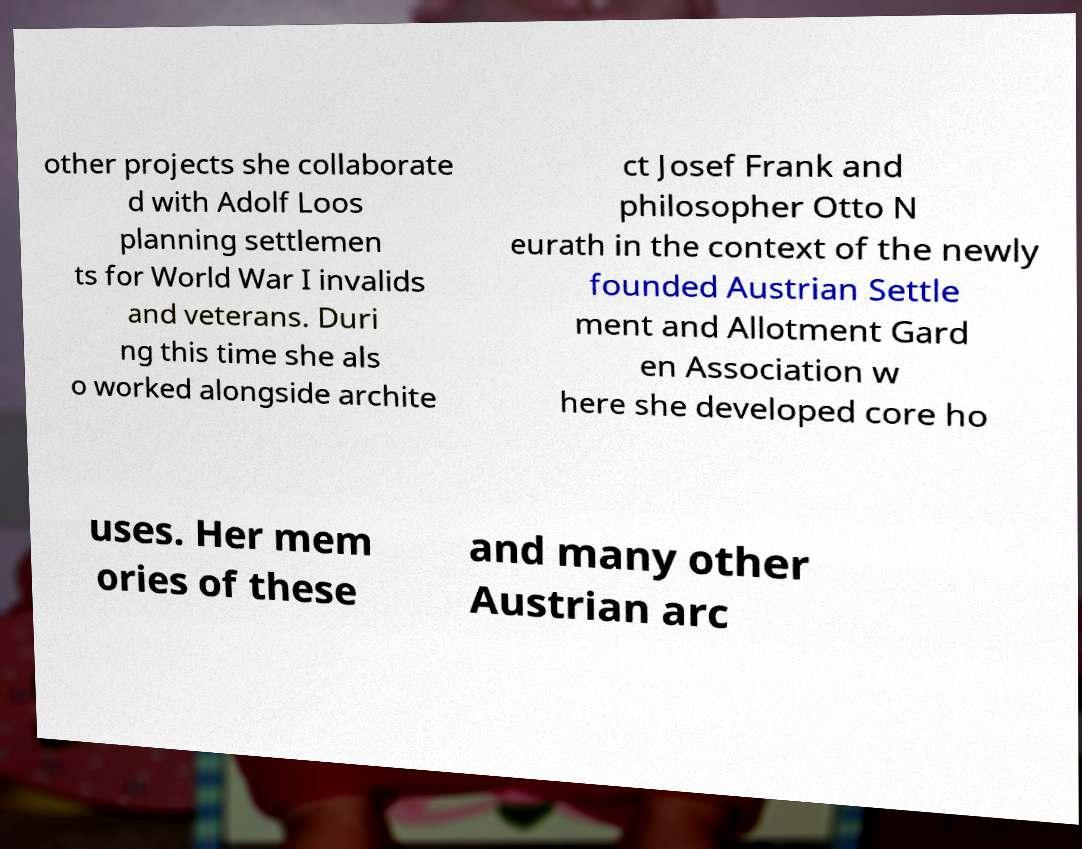For documentation purposes, I need the text within this image transcribed. Could you provide that? other projects she collaborate d with Adolf Loos planning settlemen ts for World War I invalids and veterans. Duri ng this time she als o worked alongside archite ct Josef Frank and philosopher Otto N eurath in the context of the newly founded Austrian Settle ment and Allotment Gard en Association w here she developed core ho uses. Her mem ories of these and many other Austrian arc 